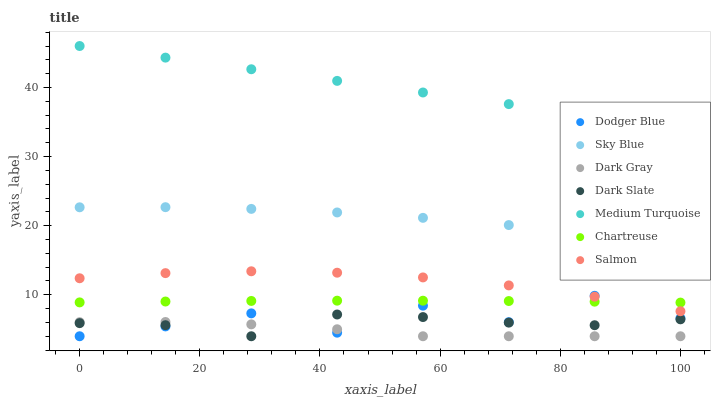Does Dark Gray have the minimum area under the curve?
Answer yes or no. Yes. Does Medium Turquoise have the maximum area under the curve?
Answer yes or no. Yes. Does Dark Slate have the minimum area under the curve?
Answer yes or no. No. Does Dark Slate have the maximum area under the curve?
Answer yes or no. No. Is Medium Turquoise the smoothest?
Answer yes or no. Yes. Is Dodger Blue the roughest?
Answer yes or no. Yes. Is Dark Gray the smoothest?
Answer yes or no. No. Is Dark Gray the roughest?
Answer yes or no. No. Does Dark Gray have the lowest value?
Answer yes or no. Yes. Does Chartreuse have the lowest value?
Answer yes or no. No. Does Medium Turquoise have the highest value?
Answer yes or no. Yes. Does Dark Slate have the highest value?
Answer yes or no. No. Is Dark Gray less than Sky Blue?
Answer yes or no. Yes. Is Sky Blue greater than Salmon?
Answer yes or no. Yes. Does Dark Gray intersect Dodger Blue?
Answer yes or no. Yes. Is Dark Gray less than Dodger Blue?
Answer yes or no. No. Is Dark Gray greater than Dodger Blue?
Answer yes or no. No. Does Dark Gray intersect Sky Blue?
Answer yes or no. No. 